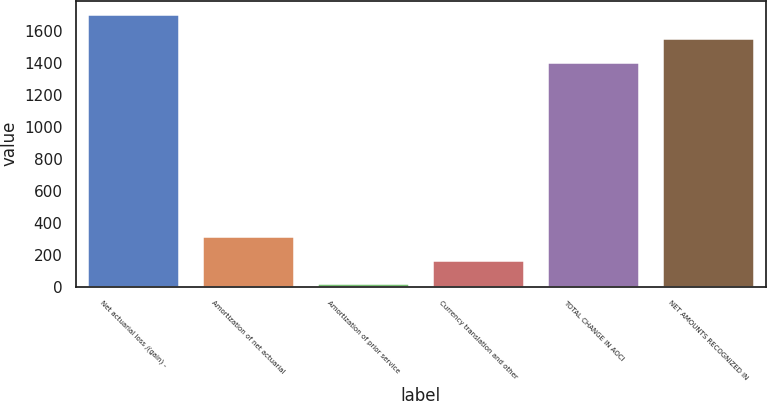Convert chart. <chart><loc_0><loc_0><loc_500><loc_500><bar_chart><fcel>Net actuarial loss /(gain) -<fcel>Amortization of net actuarial<fcel>Amortization of prior service<fcel>Currency translation and other<fcel>TOTAL CHANGE IN AOCI<fcel>NET AMOUNTS RECOGNIZED IN<nl><fcel>1700.2<fcel>319.2<fcel>20<fcel>169.6<fcel>1401<fcel>1550.6<nl></chart> 